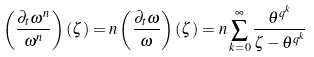Convert formula to latex. <formula><loc_0><loc_0><loc_500><loc_500>\left ( \frac { \partial _ { t } \omega ^ { n } } { \omega ^ { n } } \right ) ( \zeta ) = n \left ( \frac { \partial _ { t } \omega } { \omega } \right ) ( \zeta ) = n \sum _ { k = 0 } ^ { \infty } { \frac { \theta ^ { q ^ { k } } } { \zeta - \theta ^ { q ^ { k } } } }</formula> 